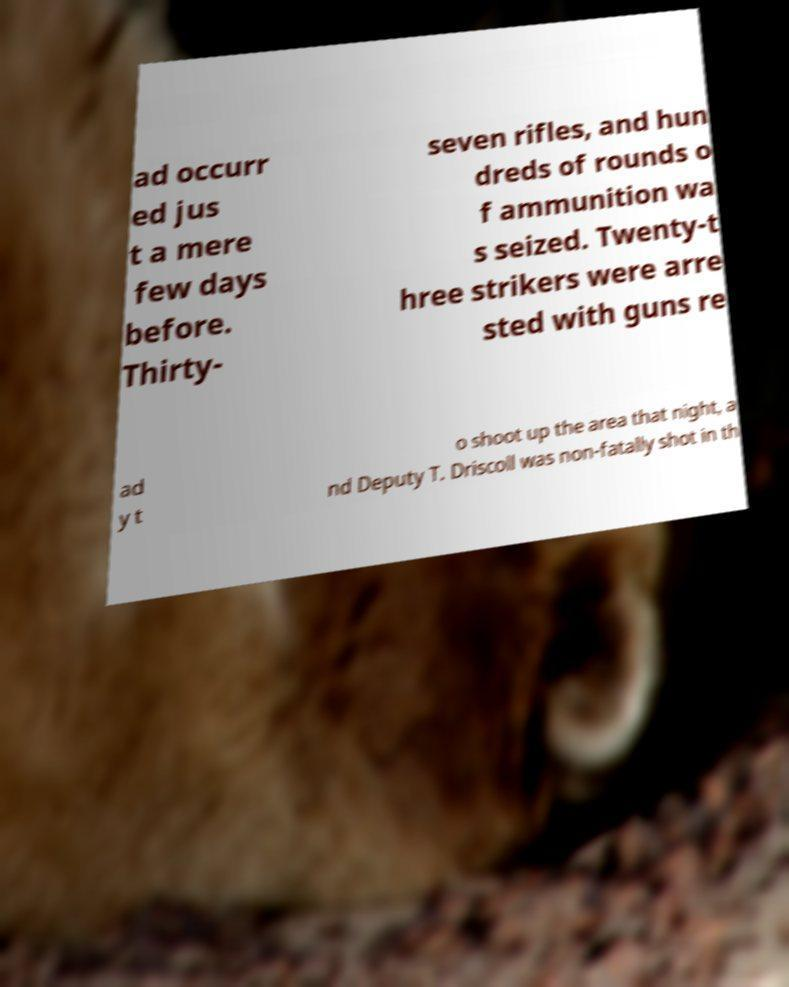I need the written content from this picture converted into text. Can you do that? ad occurr ed jus t a mere few days before. Thirty- seven rifles, and hun dreds of rounds o f ammunition wa s seized. Twenty-t hree strikers were arre sted with guns re ad y t o shoot up the area that night, a nd Deputy T. Driscoll was non-fatally shot in th 